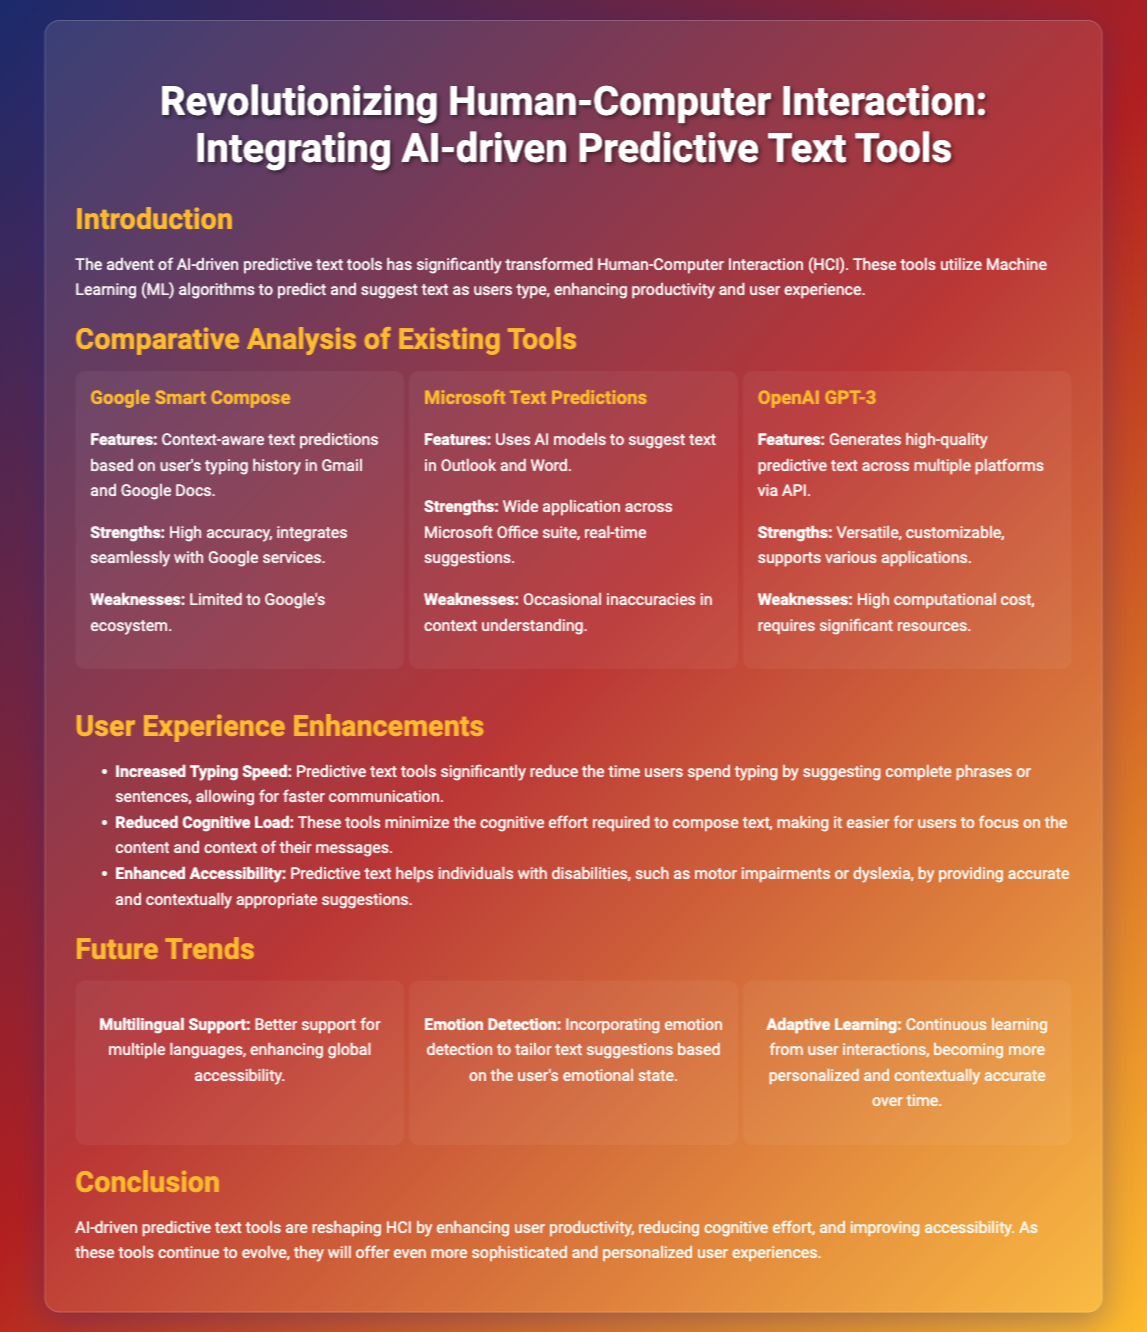What is the title of the presentation? The title of the presentation is prominently displayed at the top of the document.
Answer: Revolutionizing Human-Computer Interaction: Integrating AI-driven Predictive Text Tools What features does Google Smart Compose provide? The features of Google Smart Compose can be found in the comparative analysis section, specifically under its tool description.
Answer: Context-aware text predictions based on user's typing history in Gmail and Google Docs What is one strength of OpenAI GPT-3? The strengths of OpenAI GPT-3 are listed in its comparative analysis section.
Answer: Versatile How does predictive text enhance typing speed? The enhancement of typing speed is summarized in the user experience section, describing how predictive text helps users.
Answer: By suggesting complete phrases or sentences What is one future trend in AI-driven predictive text tools? The future trends section lists several trends expected in the development of predictive text tools.
Answer: Multilingual Support What is a weakness of Microsoft Text Predictions? The weaknesses of Microsoft Text Predictions are outlined in the comparative analysis section.
Answer: Occasional inaccuracies in context understanding How do predictive text tools help individuals with disabilities? The benefits for individuals with disabilities are mentioned in the user experience enhancements section.
Answer: By providing accurate and contextually appropriate suggestions What is the main conclusion of the presentation? The conclusion summarizes the overall impact of AI-driven predictive text tools as outlined at the end of the document.
Answer: They are reshaping HCI by enhancing user productivity, reducing cognitive effort, and improving accessibility 